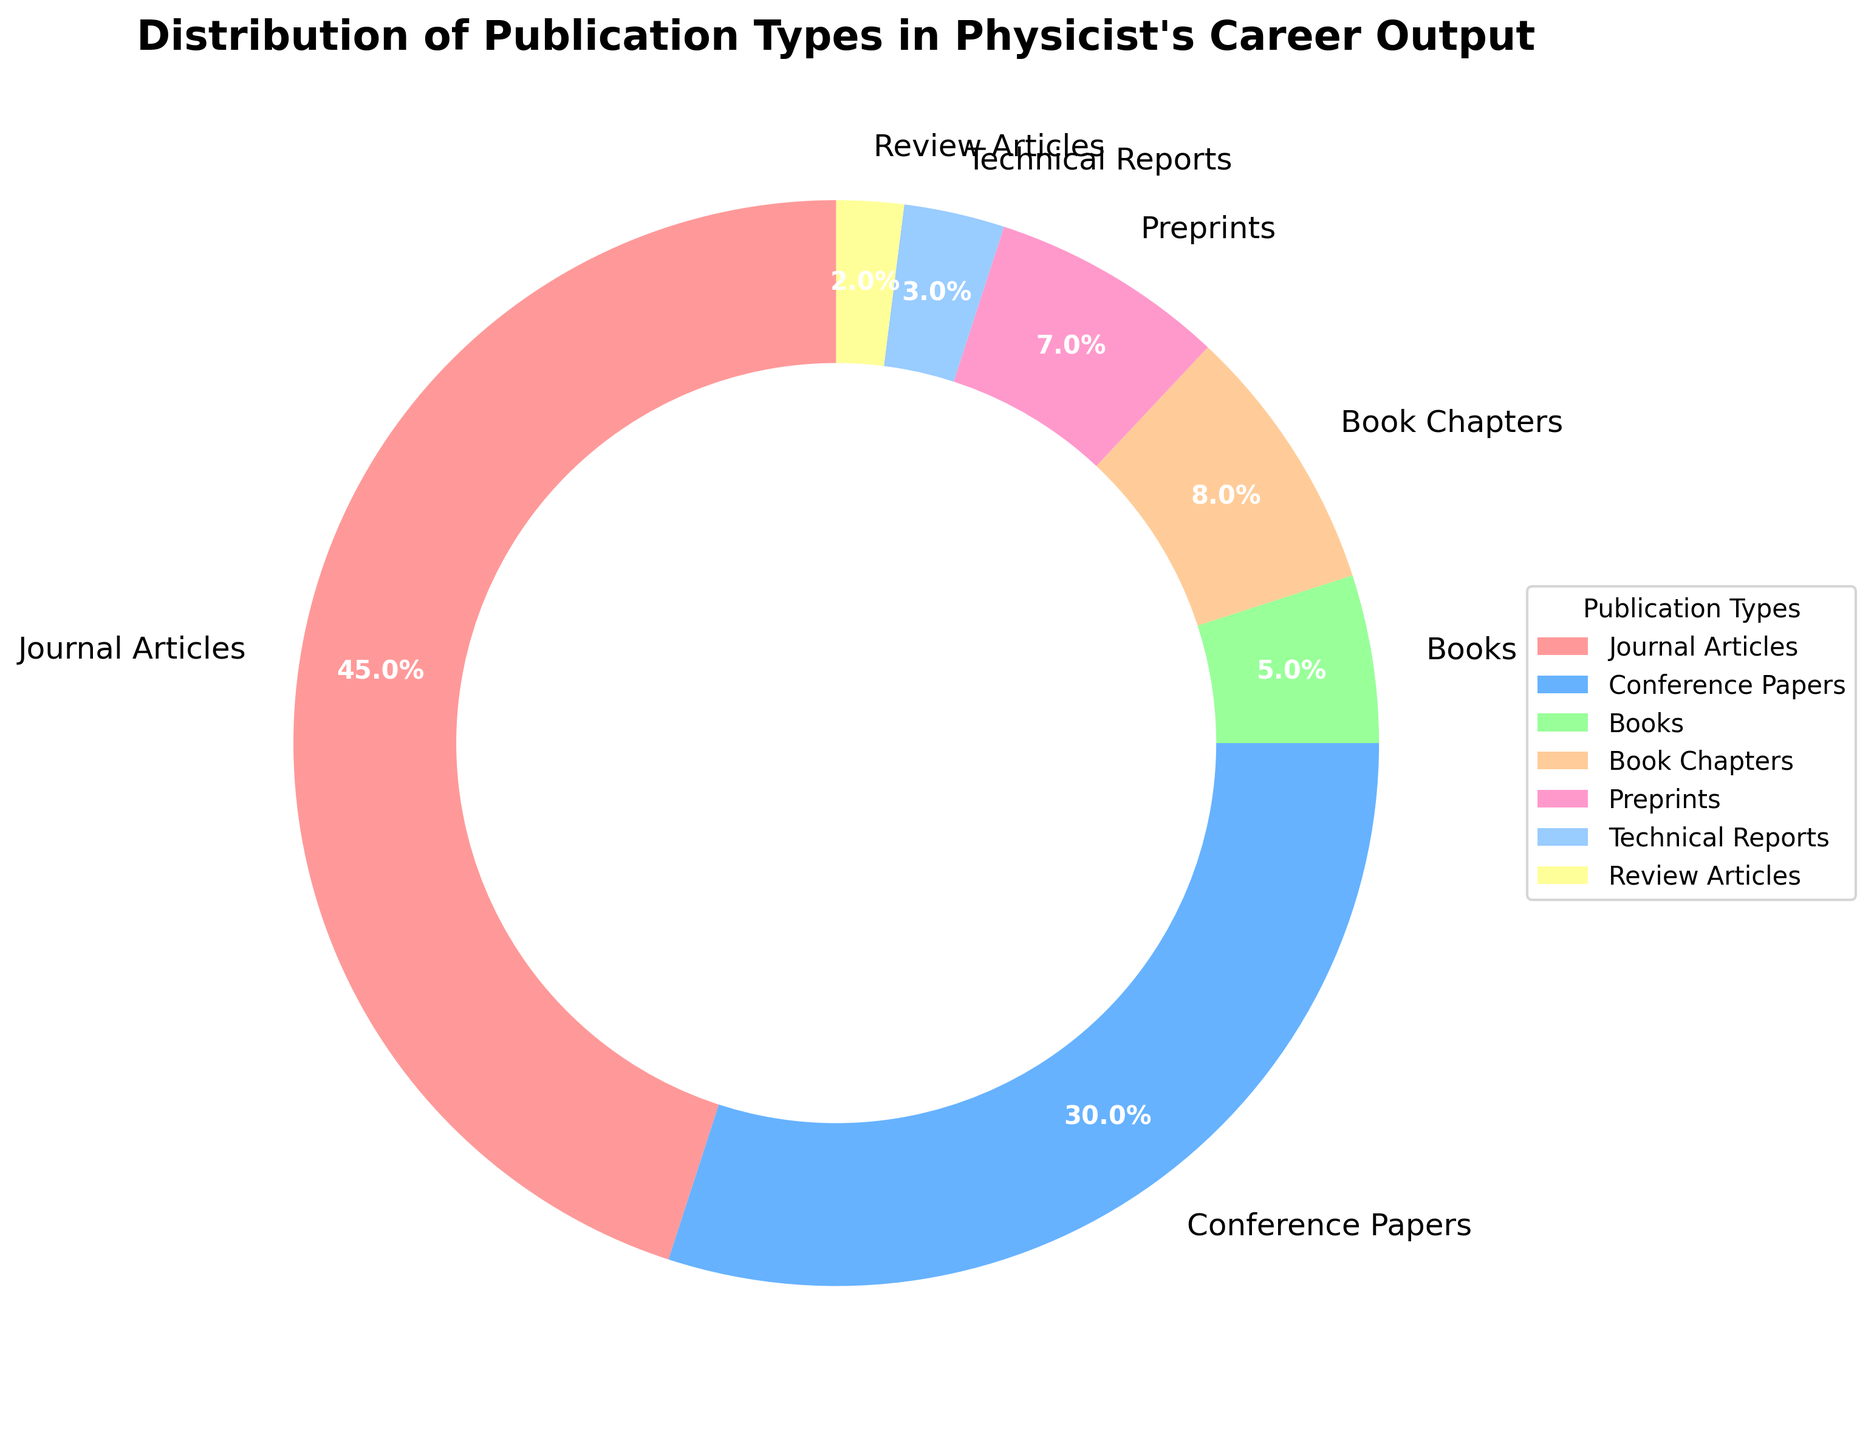What is the percentage of journal articles? Journal articles have a percentage label on the pie chart, which can be directly read.
Answer: 45% Which publication type has the smallest percentage? Compare the percentages of all publication types to find the smallest.
Answer: Review Articles What is the combined percentage of books and book chapters? Sum the percentages for books (5%) and book chapters (8%). The combined percentage is 5% + 8% = 13%.
Answer: 13% Is the percentage of conference papers greater than journal articles? Compare the percentage of conference papers (30%) with journal articles (45%). 30% is less than 45%.
Answer: No What are the colors representing journal articles and conference papers? By observing the pie chart, we find journal articles are in red, and conference papers are in blue.
Answer: red and blue How much greater is the percentage of journal articles compared to preprints? Subtract the percentage of preprints (7%) from journal articles (45%): 45% - 7% = 38%.
Answer: 38% What is the second most common type of publication? By looking at the second largest segment in the pie chart, we see that conference papers with 30% is second after journal articles.
Answer: Conference Papers Which publication types have a percentage less than 5%? Identify the sections with less than 5%: Technical Reports (3%), Review Articles (2%).
Answer: Technical Reports and Review Articles What is the average percentage of book chapters, preprints, and review articles? Add their percentages: 8% + 7% + 2% = 17% and divide by 3: 17% / 3 ≈ 5.67%.
Answer: 5.67% Which color corresponds to the smallest segment in the pie chart? The smallest segment represents Review Articles with 2% and is yellow.
Answer: yellow 